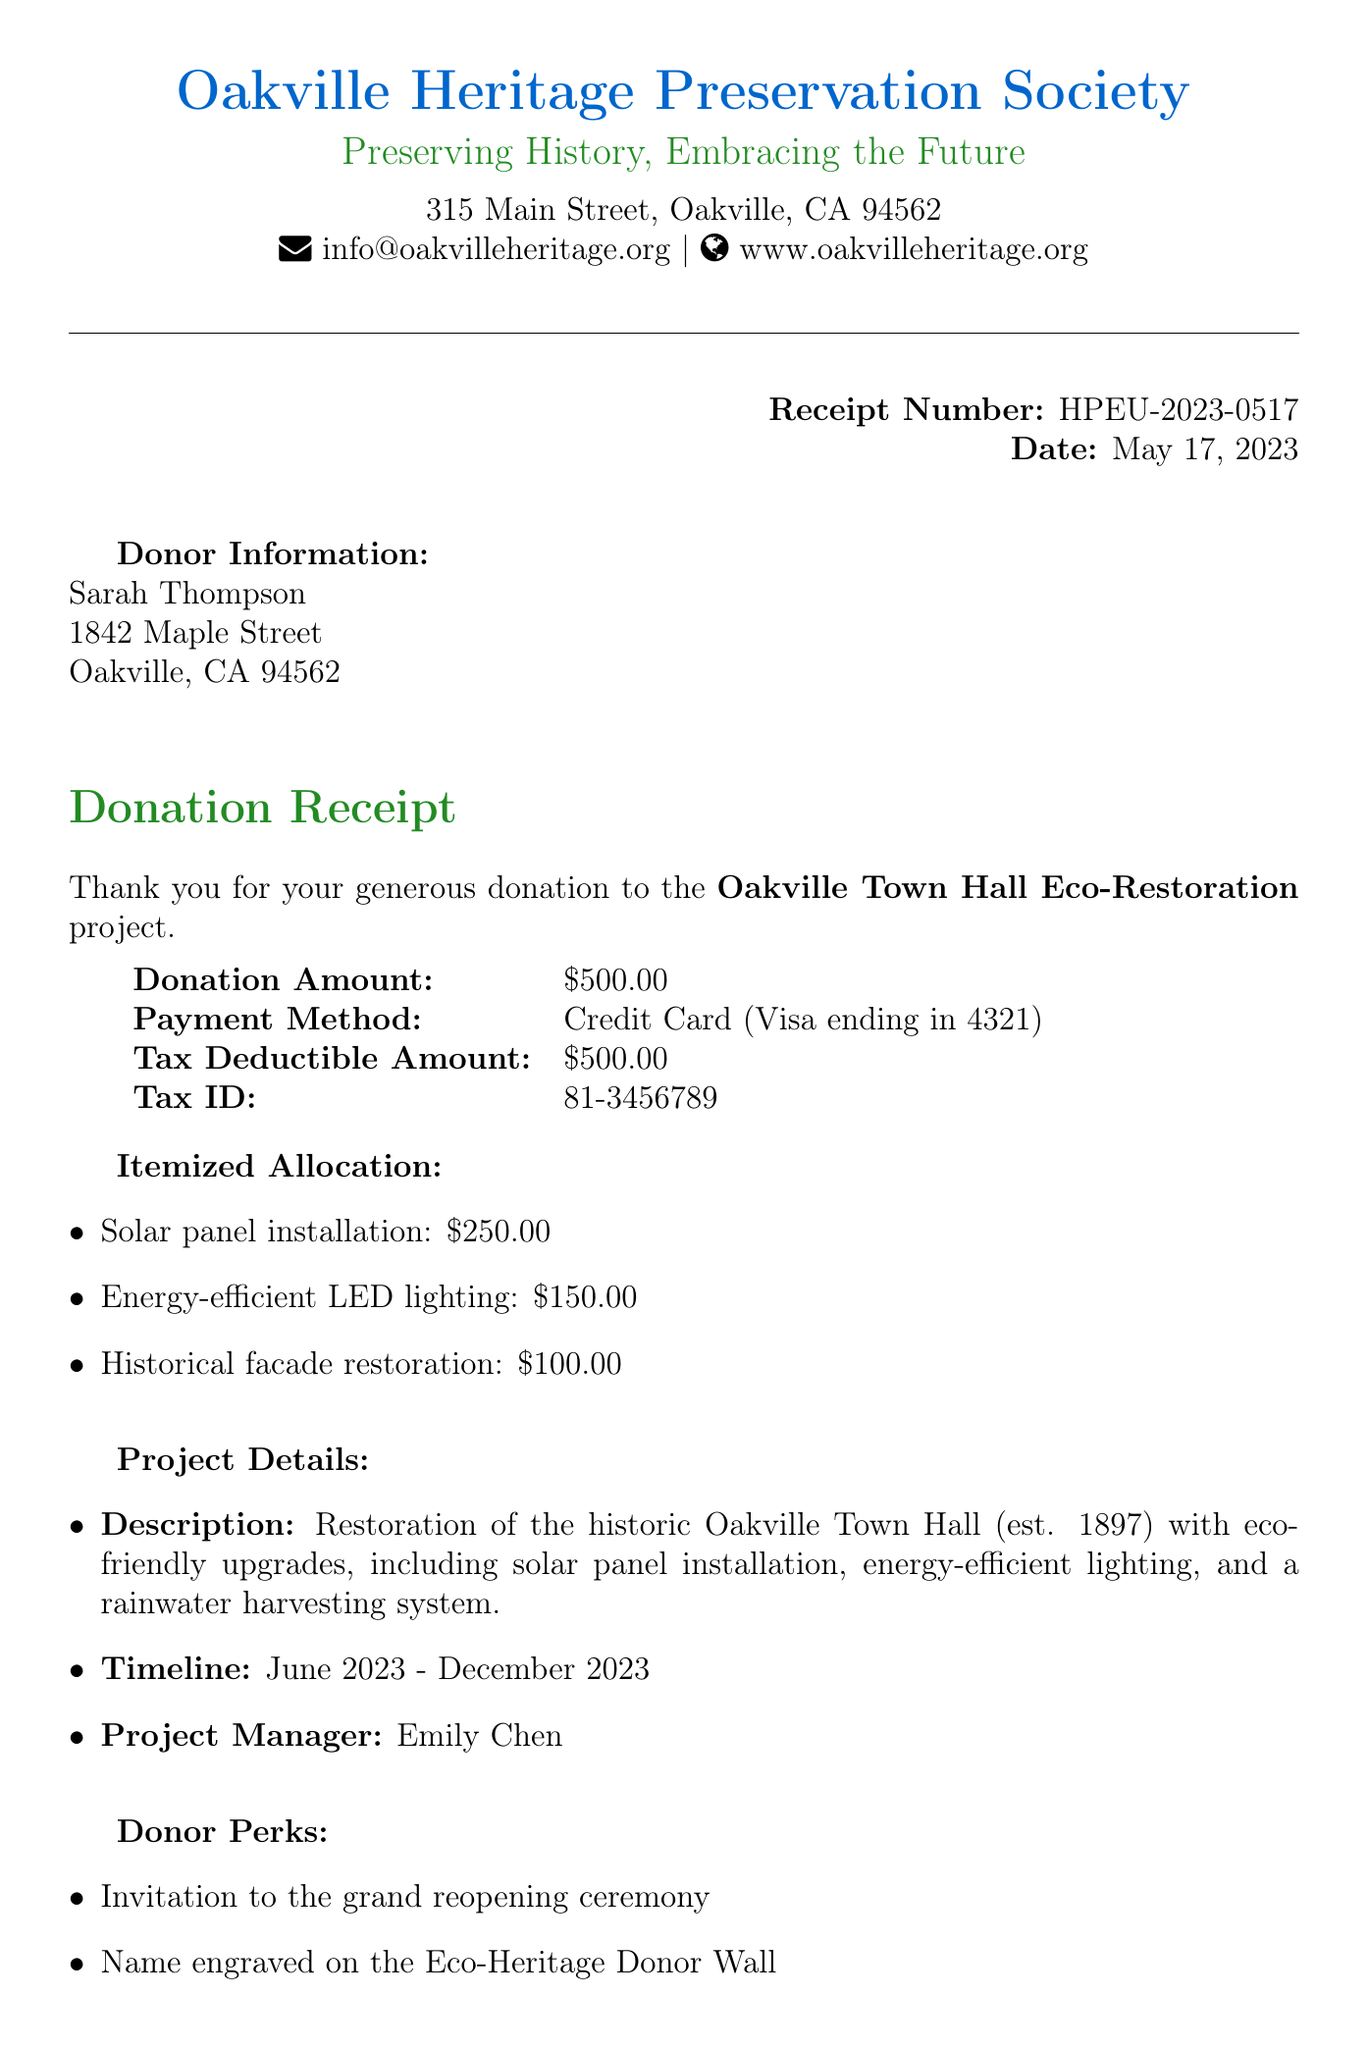What is the receipt number? The receipt number is explicitly mentioned in the document as a unique identifier.
Answer: HPEU-2023-0517 Who is the project manager? The document lists the project manager's name as part of the project details.
Answer: Emily Chen What is the donation amount? The donation amount is specified in the financial summary of the document.
Answer: $500.00 When was the donation made? The date of the donation is stated in the header of the receipt.
Answer: May 17, 2023 What is the project name? The project name is prominently featured in the document, indicating the purpose of the donation.
Answer: Oakville Town Hall Eco-Restoration How much is allocated for solar panel installation? The itemized allocation breaks down the donation into specific categories, including solar panels.
Answer: $250.00 What are the donor perks listed? Donor perks are identified in a section detailing benefits that come with the donation.
Answer: Invitation to the grand reopening ceremony, Name engraved on the Eco-Heritage Donor Wall, Exclusive tour of the restored Town Hall What is the tax deductible amount? The tax deductible amount is clearly stated for tax purposes.
Answer: $500.00 What is the project timeline? The project timeline provides a start and end date for the project duration.
Answer: June 2023 - December 2023 